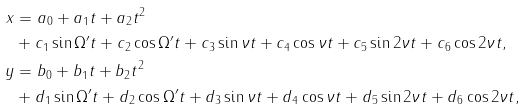Convert formula to latex. <formula><loc_0><loc_0><loc_500><loc_500>x & = a _ { 0 } + a _ { 1 } t + a _ { 2 } t ^ { 2 } \\ & + c _ { 1 } \sin \Omega ^ { \prime } t + c _ { 2 } \cos \Omega ^ { \prime } t + c _ { 3 } \sin \nu t + c _ { 4 } \cos \nu t + c _ { 5 } \sin 2 \nu t + c _ { 6 } \cos 2 \nu t , \\ y & = b _ { 0 } + b _ { 1 } t + b _ { 2 } t ^ { 2 } \\ & + d _ { 1 } \sin \Omega ^ { \prime } t + d _ { 2 } \cos \Omega ^ { \prime } t + d _ { 3 } \sin \nu t + d _ { 4 } \cos \nu t + d _ { 5 } \sin 2 \nu t + d _ { 6 } \cos 2 \nu t ,</formula> 